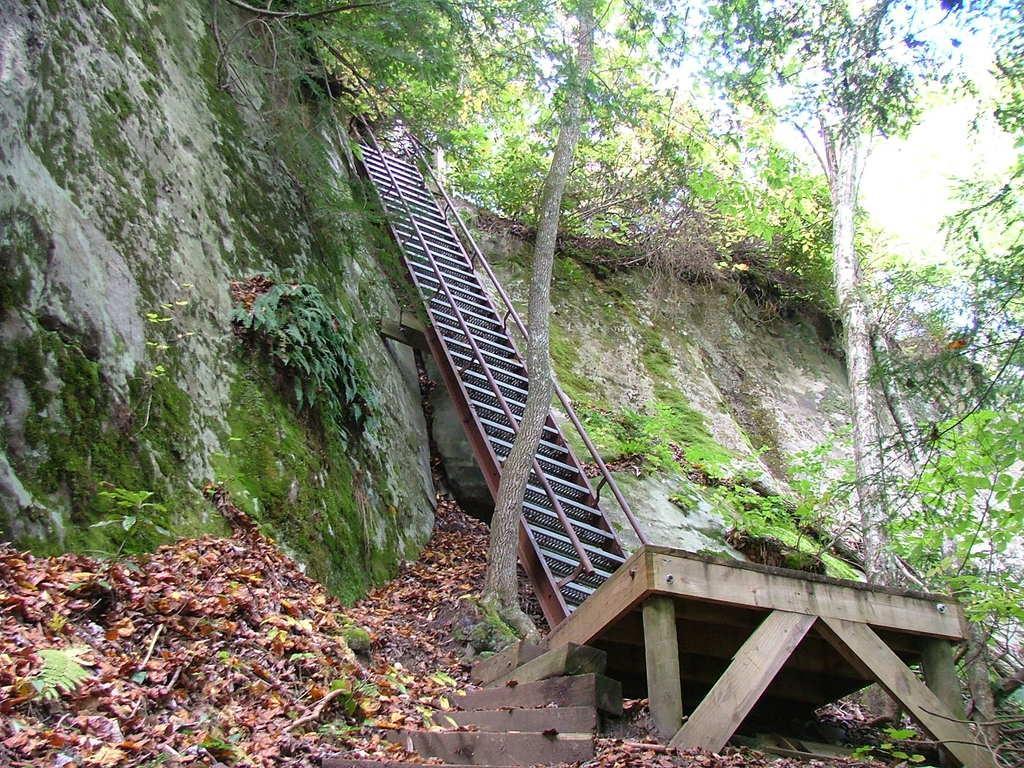Describe this image in one or two sentences. In this image I can see the dried leaves. I can also see wooden object, stairs and the railing. To the side of the stairs I can see the rock. In the background I can see many trees and the sky. 